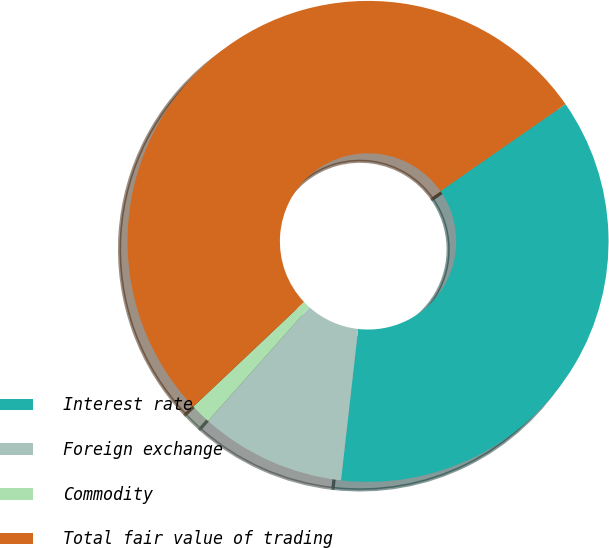<chart> <loc_0><loc_0><loc_500><loc_500><pie_chart><fcel>Interest rate<fcel>Foreign exchange<fcel>Commodity<fcel>Total fair value of trading<nl><fcel>36.46%<fcel>9.79%<fcel>1.36%<fcel>52.38%<nl></chart> 